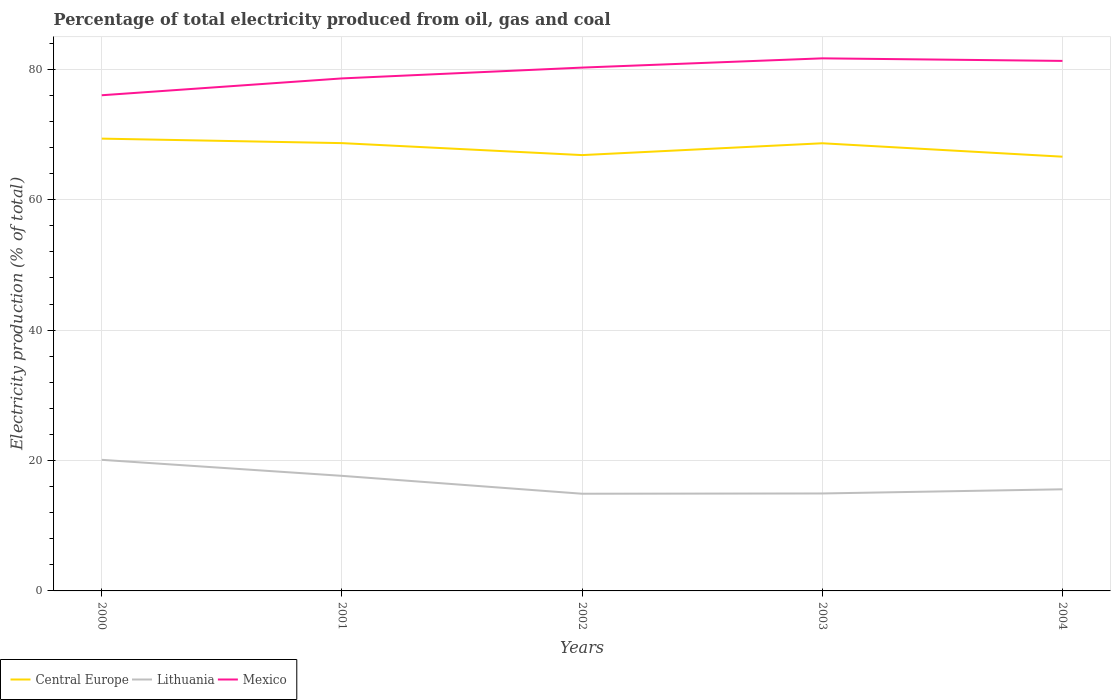How many different coloured lines are there?
Provide a succinct answer. 3. Does the line corresponding to Mexico intersect with the line corresponding to Lithuania?
Provide a short and direct response. No. Is the number of lines equal to the number of legend labels?
Keep it short and to the point. Yes. Across all years, what is the maximum electricity production in in Mexico?
Offer a very short reply. 76.02. In which year was the electricity production in in Mexico maximum?
Your response must be concise. 2000. What is the total electricity production in in Lithuania in the graph?
Your answer should be compact. -0.04. What is the difference between the highest and the second highest electricity production in in Central Europe?
Your answer should be compact. 2.77. Is the electricity production in in Central Europe strictly greater than the electricity production in in Mexico over the years?
Offer a terse response. Yes. What is the difference between two consecutive major ticks on the Y-axis?
Make the answer very short. 20. Does the graph contain grids?
Give a very brief answer. Yes. How many legend labels are there?
Offer a terse response. 3. How are the legend labels stacked?
Provide a short and direct response. Horizontal. What is the title of the graph?
Ensure brevity in your answer.  Percentage of total electricity produced from oil, gas and coal. What is the label or title of the X-axis?
Make the answer very short. Years. What is the label or title of the Y-axis?
Ensure brevity in your answer.  Electricity production (% of total). What is the Electricity production (% of total) in Central Europe in 2000?
Provide a short and direct response. 69.37. What is the Electricity production (% of total) in Lithuania in 2000?
Your answer should be compact. 20.11. What is the Electricity production (% of total) of Mexico in 2000?
Offer a very short reply. 76.02. What is the Electricity production (% of total) in Central Europe in 2001?
Provide a succinct answer. 68.68. What is the Electricity production (% of total) in Lithuania in 2001?
Provide a succinct answer. 17.65. What is the Electricity production (% of total) of Mexico in 2001?
Keep it short and to the point. 78.61. What is the Electricity production (% of total) in Central Europe in 2002?
Keep it short and to the point. 66.85. What is the Electricity production (% of total) in Lithuania in 2002?
Your response must be concise. 14.91. What is the Electricity production (% of total) of Mexico in 2002?
Your response must be concise. 80.27. What is the Electricity production (% of total) in Central Europe in 2003?
Your response must be concise. 68.66. What is the Electricity production (% of total) of Lithuania in 2003?
Provide a succinct answer. 14.95. What is the Electricity production (% of total) of Mexico in 2003?
Provide a short and direct response. 81.68. What is the Electricity production (% of total) of Central Europe in 2004?
Give a very brief answer. 66.6. What is the Electricity production (% of total) of Lithuania in 2004?
Offer a very short reply. 15.59. What is the Electricity production (% of total) of Mexico in 2004?
Your answer should be very brief. 81.29. Across all years, what is the maximum Electricity production (% of total) of Central Europe?
Provide a short and direct response. 69.37. Across all years, what is the maximum Electricity production (% of total) of Lithuania?
Keep it short and to the point. 20.11. Across all years, what is the maximum Electricity production (% of total) of Mexico?
Offer a terse response. 81.68. Across all years, what is the minimum Electricity production (% of total) of Central Europe?
Keep it short and to the point. 66.6. Across all years, what is the minimum Electricity production (% of total) of Lithuania?
Provide a short and direct response. 14.91. Across all years, what is the minimum Electricity production (% of total) of Mexico?
Your answer should be compact. 76.02. What is the total Electricity production (% of total) in Central Europe in the graph?
Ensure brevity in your answer.  340.16. What is the total Electricity production (% of total) of Lithuania in the graph?
Your answer should be very brief. 83.2. What is the total Electricity production (% of total) of Mexico in the graph?
Keep it short and to the point. 397.87. What is the difference between the Electricity production (% of total) in Central Europe in 2000 and that in 2001?
Ensure brevity in your answer.  0.69. What is the difference between the Electricity production (% of total) of Lithuania in 2000 and that in 2001?
Offer a very short reply. 2.46. What is the difference between the Electricity production (% of total) of Mexico in 2000 and that in 2001?
Provide a succinct answer. -2.58. What is the difference between the Electricity production (% of total) in Central Europe in 2000 and that in 2002?
Offer a terse response. 2.52. What is the difference between the Electricity production (% of total) of Lithuania in 2000 and that in 2002?
Keep it short and to the point. 5.2. What is the difference between the Electricity production (% of total) in Mexico in 2000 and that in 2002?
Offer a terse response. -4.24. What is the difference between the Electricity production (% of total) in Central Europe in 2000 and that in 2003?
Your answer should be compact. 0.71. What is the difference between the Electricity production (% of total) in Lithuania in 2000 and that in 2003?
Ensure brevity in your answer.  5.16. What is the difference between the Electricity production (% of total) of Mexico in 2000 and that in 2003?
Offer a very short reply. -5.66. What is the difference between the Electricity production (% of total) of Central Europe in 2000 and that in 2004?
Offer a terse response. 2.77. What is the difference between the Electricity production (% of total) of Lithuania in 2000 and that in 2004?
Your answer should be compact. 4.52. What is the difference between the Electricity production (% of total) in Mexico in 2000 and that in 2004?
Give a very brief answer. -5.27. What is the difference between the Electricity production (% of total) of Central Europe in 2001 and that in 2002?
Your response must be concise. 1.84. What is the difference between the Electricity production (% of total) of Lithuania in 2001 and that in 2002?
Your answer should be compact. 2.74. What is the difference between the Electricity production (% of total) of Mexico in 2001 and that in 2002?
Keep it short and to the point. -1.66. What is the difference between the Electricity production (% of total) in Central Europe in 2001 and that in 2003?
Your answer should be compact. 0.02. What is the difference between the Electricity production (% of total) in Lithuania in 2001 and that in 2003?
Offer a very short reply. 2.7. What is the difference between the Electricity production (% of total) of Mexico in 2001 and that in 2003?
Provide a succinct answer. -3.08. What is the difference between the Electricity production (% of total) of Central Europe in 2001 and that in 2004?
Your response must be concise. 2.08. What is the difference between the Electricity production (% of total) of Lithuania in 2001 and that in 2004?
Provide a succinct answer. 2.06. What is the difference between the Electricity production (% of total) of Mexico in 2001 and that in 2004?
Provide a short and direct response. -2.69. What is the difference between the Electricity production (% of total) of Central Europe in 2002 and that in 2003?
Offer a very short reply. -1.81. What is the difference between the Electricity production (% of total) in Lithuania in 2002 and that in 2003?
Your response must be concise. -0.04. What is the difference between the Electricity production (% of total) in Mexico in 2002 and that in 2003?
Your answer should be compact. -1.42. What is the difference between the Electricity production (% of total) of Central Europe in 2002 and that in 2004?
Your answer should be compact. 0.24. What is the difference between the Electricity production (% of total) in Lithuania in 2002 and that in 2004?
Your response must be concise. -0.68. What is the difference between the Electricity production (% of total) of Mexico in 2002 and that in 2004?
Your answer should be very brief. -1.03. What is the difference between the Electricity production (% of total) of Central Europe in 2003 and that in 2004?
Make the answer very short. 2.06. What is the difference between the Electricity production (% of total) of Lithuania in 2003 and that in 2004?
Keep it short and to the point. -0.64. What is the difference between the Electricity production (% of total) of Mexico in 2003 and that in 2004?
Your response must be concise. 0.39. What is the difference between the Electricity production (% of total) in Central Europe in 2000 and the Electricity production (% of total) in Lithuania in 2001?
Offer a very short reply. 51.72. What is the difference between the Electricity production (% of total) of Central Europe in 2000 and the Electricity production (% of total) of Mexico in 2001?
Give a very brief answer. -9.24. What is the difference between the Electricity production (% of total) in Lithuania in 2000 and the Electricity production (% of total) in Mexico in 2001?
Provide a short and direct response. -58.5. What is the difference between the Electricity production (% of total) in Central Europe in 2000 and the Electricity production (% of total) in Lithuania in 2002?
Your answer should be compact. 54.46. What is the difference between the Electricity production (% of total) in Central Europe in 2000 and the Electricity production (% of total) in Mexico in 2002?
Your answer should be very brief. -10.89. What is the difference between the Electricity production (% of total) of Lithuania in 2000 and the Electricity production (% of total) of Mexico in 2002?
Your response must be concise. -60.16. What is the difference between the Electricity production (% of total) in Central Europe in 2000 and the Electricity production (% of total) in Lithuania in 2003?
Ensure brevity in your answer.  54.43. What is the difference between the Electricity production (% of total) of Central Europe in 2000 and the Electricity production (% of total) of Mexico in 2003?
Offer a terse response. -12.31. What is the difference between the Electricity production (% of total) of Lithuania in 2000 and the Electricity production (% of total) of Mexico in 2003?
Ensure brevity in your answer.  -61.58. What is the difference between the Electricity production (% of total) of Central Europe in 2000 and the Electricity production (% of total) of Lithuania in 2004?
Offer a terse response. 53.78. What is the difference between the Electricity production (% of total) of Central Europe in 2000 and the Electricity production (% of total) of Mexico in 2004?
Offer a terse response. -11.92. What is the difference between the Electricity production (% of total) in Lithuania in 2000 and the Electricity production (% of total) in Mexico in 2004?
Provide a short and direct response. -61.19. What is the difference between the Electricity production (% of total) of Central Europe in 2001 and the Electricity production (% of total) of Lithuania in 2002?
Offer a very short reply. 53.77. What is the difference between the Electricity production (% of total) of Central Europe in 2001 and the Electricity production (% of total) of Mexico in 2002?
Give a very brief answer. -11.58. What is the difference between the Electricity production (% of total) of Lithuania in 2001 and the Electricity production (% of total) of Mexico in 2002?
Make the answer very short. -62.61. What is the difference between the Electricity production (% of total) of Central Europe in 2001 and the Electricity production (% of total) of Lithuania in 2003?
Your answer should be compact. 53.74. What is the difference between the Electricity production (% of total) in Central Europe in 2001 and the Electricity production (% of total) in Mexico in 2003?
Offer a very short reply. -13. What is the difference between the Electricity production (% of total) of Lithuania in 2001 and the Electricity production (% of total) of Mexico in 2003?
Your answer should be very brief. -64.03. What is the difference between the Electricity production (% of total) of Central Europe in 2001 and the Electricity production (% of total) of Lithuania in 2004?
Make the answer very short. 53.09. What is the difference between the Electricity production (% of total) of Central Europe in 2001 and the Electricity production (% of total) of Mexico in 2004?
Your answer should be very brief. -12.61. What is the difference between the Electricity production (% of total) in Lithuania in 2001 and the Electricity production (% of total) in Mexico in 2004?
Give a very brief answer. -63.64. What is the difference between the Electricity production (% of total) in Central Europe in 2002 and the Electricity production (% of total) in Lithuania in 2003?
Your response must be concise. 51.9. What is the difference between the Electricity production (% of total) of Central Europe in 2002 and the Electricity production (% of total) of Mexico in 2003?
Keep it short and to the point. -14.84. What is the difference between the Electricity production (% of total) in Lithuania in 2002 and the Electricity production (% of total) in Mexico in 2003?
Give a very brief answer. -66.78. What is the difference between the Electricity production (% of total) in Central Europe in 2002 and the Electricity production (% of total) in Lithuania in 2004?
Give a very brief answer. 51.26. What is the difference between the Electricity production (% of total) in Central Europe in 2002 and the Electricity production (% of total) in Mexico in 2004?
Keep it short and to the point. -14.45. What is the difference between the Electricity production (% of total) of Lithuania in 2002 and the Electricity production (% of total) of Mexico in 2004?
Keep it short and to the point. -66.39. What is the difference between the Electricity production (% of total) of Central Europe in 2003 and the Electricity production (% of total) of Lithuania in 2004?
Your response must be concise. 53.07. What is the difference between the Electricity production (% of total) of Central Europe in 2003 and the Electricity production (% of total) of Mexico in 2004?
Your answer should be very brief. -12.63. What is the difference between the Electricity production (% of total) of Lithuania in 2003 and the Electricity production (% of total) of Mexico in 2004?
Offer a very short reply. -66.35. What is the average Electricity production (% of total) in Central Europe per year?
Your response must be concise. 68.03. What is the average Electricity production (% of total) of Lithuania per year?
Make the answer very short. 16.64. What is the average Electricity production (% of total) of Mexico per year?
Your answer should be compact. 79.57. In the year 2000, what is the difference between the Electricity production (% of total) of Central Europe and Electricity production (% of total) of Lithuania?
Offer a terse response. 49.26. In the year 2000, what is the difference between the Electricity production (% of total) of Central Europe and Electricity production (% of total) of Mexico?
Provide a short and direct response. -6.65. In the year 2000, what is the difference between the Electricity production (% of total) of Lithuania and Electricity production (% of total) of Mexico?
Provide a short and direct response. -55.92. In the year 2001, what is the difference between the Electricity production (% of total) of Central Europe and Electricity production (% of total) of Lithuania?
Provide a short and direct response. 51.03. In the year 2001, what is the difference between the Electricity production (% of total) of Central Europe and Electricity production (% of total) of Mexico?
Your answer should be very brief. -9.93. In the year 2001, what is the difference between the Electricity production (% of total) in Lithuania and Electricity production (% of total) in Mexico?
Offer a very short reply. -60.96. In the year 2002, what is the difference between the Electricity production (% of total) of Central Europe and Electricity production (% of total) of Lithuania?
Your answer should be very brief. 51.94. In the year 2002, what is the difference between the Electricity production (% of total) of Central Europe and Electricity production (% of total) of Mexico?
Offer a terse response. -13.42. In the year 2002, what is the difference between the Electricity production (% of total) of Lithuania and Electricity production (% of total) of Mexico?
Provide a succinct answer. -65.36. In the year 2003, what is the difference between the Electricity production (% of total) of Central Europe and Electricity production (% of total) of Lithuania?
Provide a succinct answer. 53.71. In the year 2003, what is the difference between the Electricity production (% of total) of Central Europe and Electricity production (% of total) of Mexico?
Your response must be concise. -13.02. In the year 2003, what is the difference between the Electricity production (% of total) in Lithuania and Electricity production (% of total) in Mexico?
Ensure brevity in your answer.  -66.74. In the year 2004, what is the difference between the Electricity production (% of total) in Central Europe and Electricity production (% of total) in Lithuania?
Keep it short and to the point. 51.01. In the year 2004, what is the difference between the Electricity production (% of total) of Central Europe and Electricity production (% of total) of Mexico?
Make the answer very short. -14.69. In the year 2004, what is the difference between the Electricity production (% of total) of Lithuania and Electricity production (% of total) of Mexico?
Your answer should be very brief. -65.71. What is the ratio of the Electricity production (% of total) of Central Europe in 2000 to that in 2001?
Your answer should be compact. 1.01. What is the ratio of the Electricity production (% of total) of Lithuania in 2000 to that in 2001?
Your answer should be compact. 1.14. What is the ratio of the Electricity production (% of total) of Mexico in 2000 to that in 2001?
Your response must be concise. 0.97. What is the ratio of the Electricity production (% of total) in Central Europe in 2000 to that in 2002?
Ensure brevity in your answer.  1.04. What is the ratio of the Electricity production (% of total) of Lithuania in 2000 to that in 2002?
Ensure brevity in your answer.  1.35. What is the ratio of the Electricity production (% of total) of Mexico in 2000 to that in 2002?
Offer a very short reply. 0.95. What is the ratio of the Electricity production (% of total) in Central Europe in 2000 to that in 2003?
Offer a very short reply. 1.01. What is the ratio of the Electricity production (% of total) in Lithuania in 2000 to that in 2003?
Provide a short and direct response. 1.35. What is the ratio of the Electricity production (% of total) in Mexico in 2000 to that in 2003?
Provide a short and direct response. 0.93. What is the ratio of the Electricity production (% of total) of Central Europe in 2000 to that in 2004?
Your answer should be very brief. 1.04. What is the ratio of the Electricity production (% of total) in Lithuania in 2000 to that in 2004?
Offer a terse response. 1.29. What is the ratio of the Electricity production (% of total) in Mexico in 2000 to that in 2004?
Keep it short and to the point. 0.94. What is the ratio of the Electricity production (% of total) of Central Europe in 2001 to that in 2002?
Give a very brief answer. 1.03. What is the ratio of the Electricity production (% of total) of Lithuania in 2001 to that in 2002?
Give a very brief answer. 1.18. What is the ratio of the Electricity production (% of total) of Mexico in 2001 to that in 2002?
Provide a short and direct response. 0.98. What is the ratio of the Electricity production (% of total) of Lithuania in 2001 to that in 2003?
Make the answer very short. 1.18. What is the ratio of the Electricity production (% of total) of Mexico in 2001 to that in 2003?
Give a very brief answer. 0.96. What is the ratio of the Electricity production (% of total) in Central Europe in 2001 to that in 2004?
Your answer should be very brief. 1.03. What is the ratio of the Electricity production (% of total) of Lithuania in 2001 to that in 2004?
Provide a short and direct response. 1.13. What is the ratio of the Electricity production (% of total) of Central Europe in 2002 to that in 2003?
Offer a very short reply. 0.97. What is the ratio of the Electricity production (% of total) in Lithuania in 2002 to that in 2003?
Give a very brief answer. 1. What is the ratio of the Electricity production (% of total) in Mexico in 2002 to that in 2003?
Give a very brief answer. 0.98. What is the ratio of the Electricity production (% of total) in Lithuania in 2002 to that in 2004?
Your answer should be compact. 0.96. What is the ratio of the Electricity production (% of total) of Mexico in 2002 to that in 2004?
Your response must be concise. 0.99. What is the ratio of the Electricity production (% of total) of Central Europe in 2003 to that in 2004?
Provide a succinct answer. 1.03. What is the ratio of the Electricity production (% of total) in Lithuania in 2003 to that in 2004?
Ensure brevity in your answer.  0.96. What is the ratio of the Electricity production (% of total) in Mexico in 2003 to that in 2004?
Provide a succinct answer. 1. What is the difference between the highest and the second highest Electricity production (% of total) in Central Europe?
Offer a very short reply. 0.69. What is the difference between the highest and the second highest Electricity production (% of total) of Lithuania?
Your answer should be compact. 2.46. What is the difference between the highest and the second highest Electricity production (% of total) in Mexico?
Give a very brief answer. 0.39. What is the difference between the highest and the lowest Electricity production (% of total) of Central Europe?
Offer a very short reply. 2.77. What is the difference between the highest and the lowest Electricity production (% of total) of Lithuania?
Provide a succinct answer. 5.2. What is the difference between the highest and the lowest Electricity production (% of total) in Mexico?
Your answer should be very brief. 5.66. 